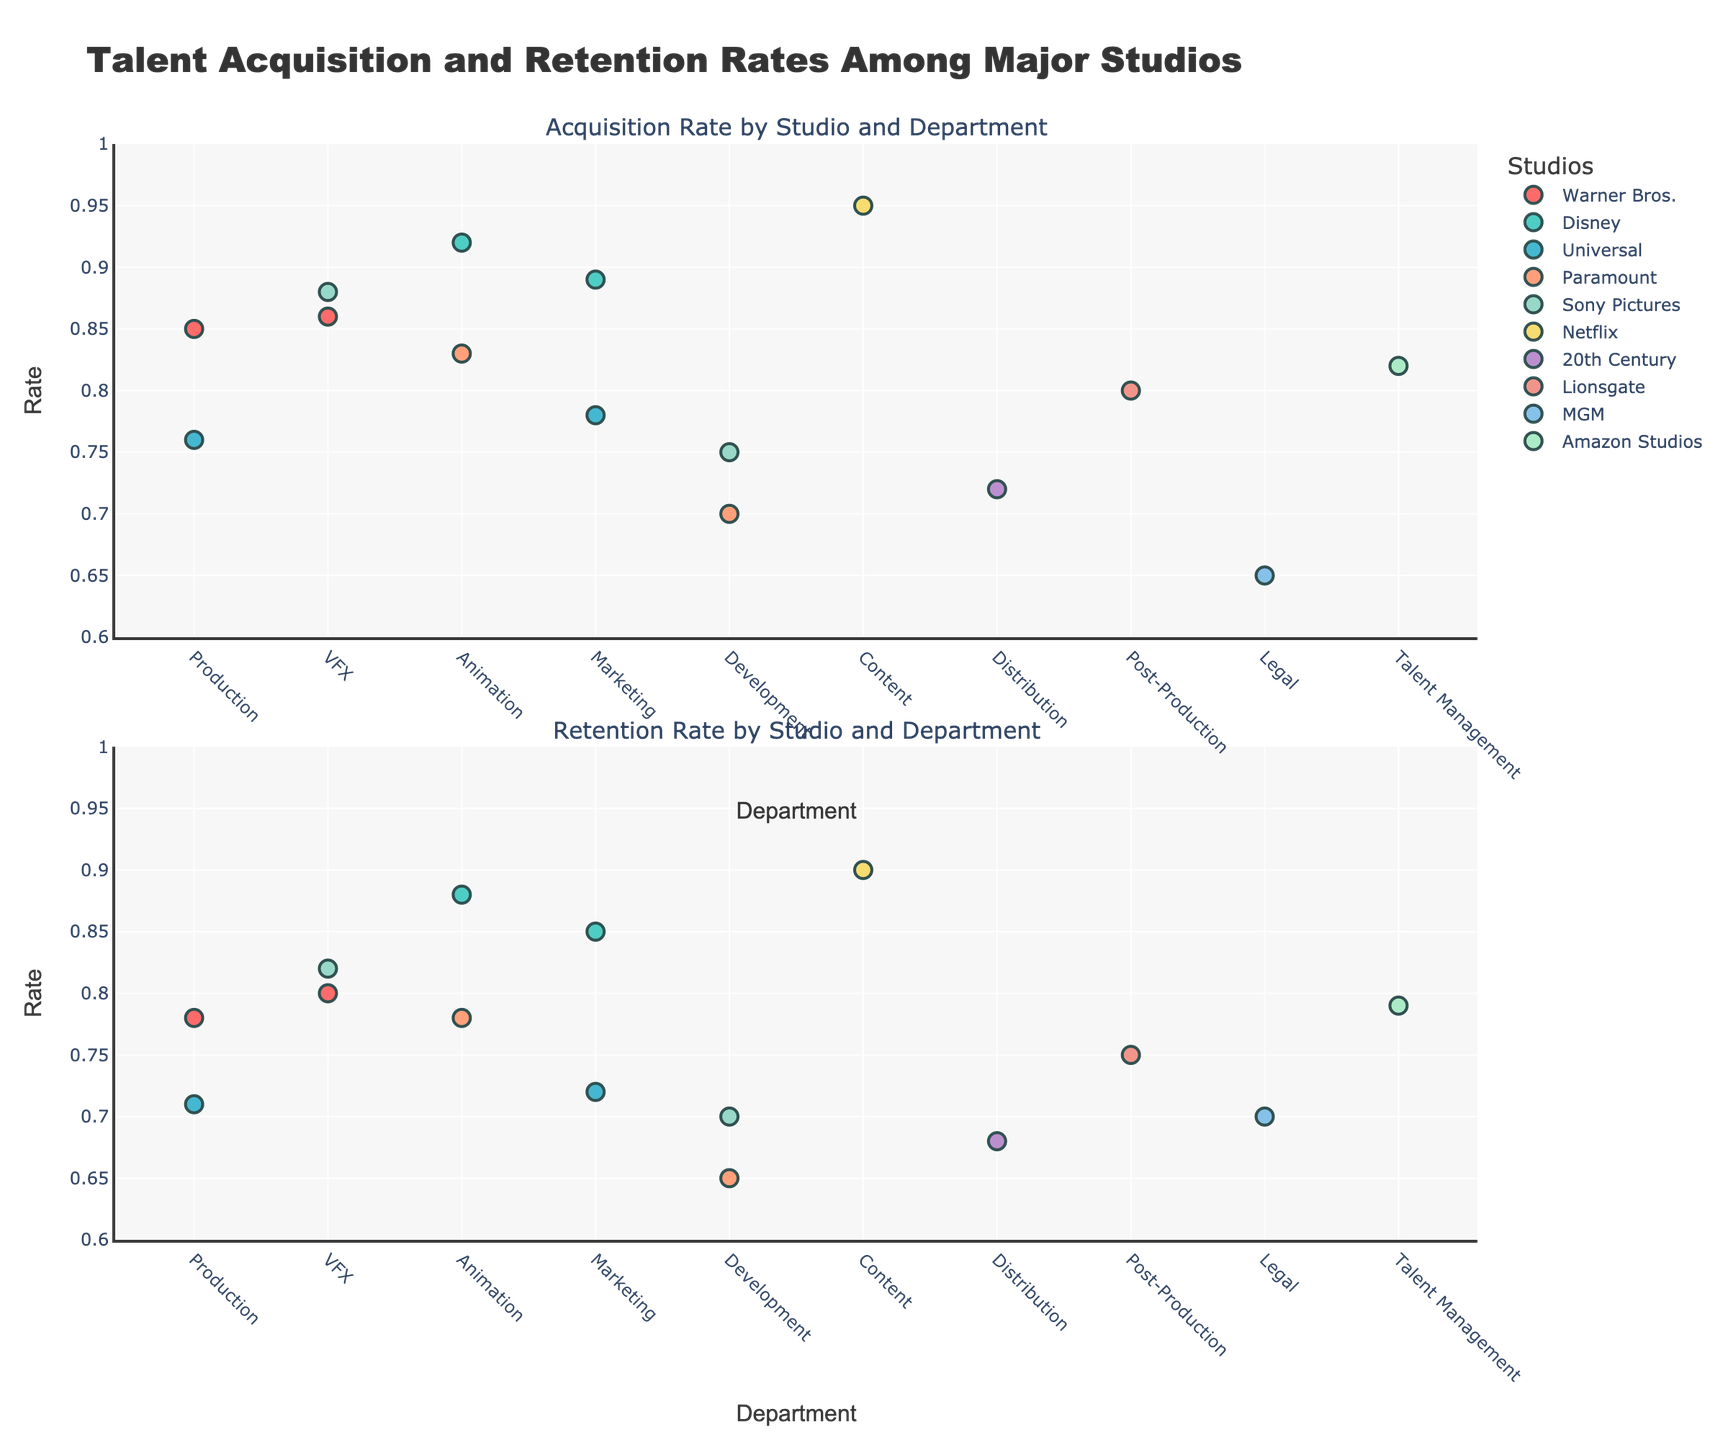What is the title of the figure? The title of the figure is displayed at the top and it reads "Talent Acquisition and Retention Rates Among Major Studios".
Answer: Talent Acquisition and Retention Rates Among Major Studios Which department has the highest acquisition rate in the Animation department? From the first subplot, you can see that Disney in the Animation department shows the highest acquisition rate.
Answer: Disney Which studio has the lowest retention rate and in which department? The lowest retention rate is shown in the Entertainment Lawyer role of MGM's Legal department in the second subplot.
Answer: MGM, Legal How many data points are in the Production department? In both subplots, there are data points for Warner Bros. and Universal in the Production department, which makes a total of 2 data points.
Answer: 2 Which department has the highest difference between acquisition and retention rates, and which studio does it belong to? By calculating the difference between acquisition and retention rates for each department, the Development department at Paramount has the highest difference (0.70 - 0.65 = 0.05).
Answer: Paramount, Development Which studio excels most in the Marketing department based on retention rates? Comparing the retention rates in Marketing, Disney's Brand Manager role shows the higher retention rate among the studios.
Answer: Disney Are there any departments where the retention rate is higher than the acquisition rate? One would need to check the second subplot to see if any retention rate data points are above their corresponding acquisition rate data points on the first subplot. The MGM's Legal department (Entertainment Lawyer) is such a case where retention (0.70) is higher than acquisition (0.65).
Answer: Yes, MGM's Legal department Calculate the average acquisition rate for Netflix and Disney combined. The acquisition rates for Netflix and Disney are 0.95 and 0.92 (Animation) + 0.89 (Marketing). The mean is (0.95 + 0.92 + 0.89) / 3 = 2.76 / 3 ≈ 0.92.
Answer: 0.92 How many departments are represented by Universal studio? By looking at the different departments in which Universal is mentioned in both subplots, Universal has data points in the Marketing and Production departments, totaling 2 departments.
Answer: 2 